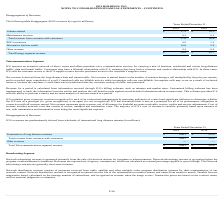According to Hc2 Holdings's financial document, When did the U.S. Congress pass the alternative fuel tax credit ("AFTC")? Based on the financial document, the answer is December 2019. Also, What was the net revenue after customer rebates for credits recognized in 2019? Based on the financial document, the answer is $10.6 million. Also, What was the Total Energy segment revenue in 2019? According to the financial document, $ 39.0 (in millions). The relevant text states: "Total Energy segment revenue $ 39.0 $ 20.7..." Also, can you calculate: What was the change in the volume-related revenue from 2018 to 2019? Based on the calculation: 27.5 - 16.5, the result is 11 (in millions). This is based on the information: "Volume-related $ 27.5 $ 16.5 Volume-related $ 27.5 $ 16.5..." The key data points involved are: 16.5, 27.5. Also, can you calculate: What was the average maintenance services revenue for 2018 and 2019? To answer this question, I need to perform calculations using the financial data. The calculation is: (0.1 + 0.1) / 2, which equals 0.1 (in millions). This is based on the information: "Maintenance services 0.1 0.1..." Also, can you calculate: What is the percentage change in the total revenue from contracts with customers from 2018 to 2019? To answer this question, I need to perform calculations using the financial data. The calculation is: 27.6 / 16.6 - 1, which equals 66.27 (percentage). This is based on the information: "Total revenue from contracts with customers 27.6 16.6 Total revenue from contracts with customers 27.6 16.6..." The key data points involved are: 16.6, 27.6. 